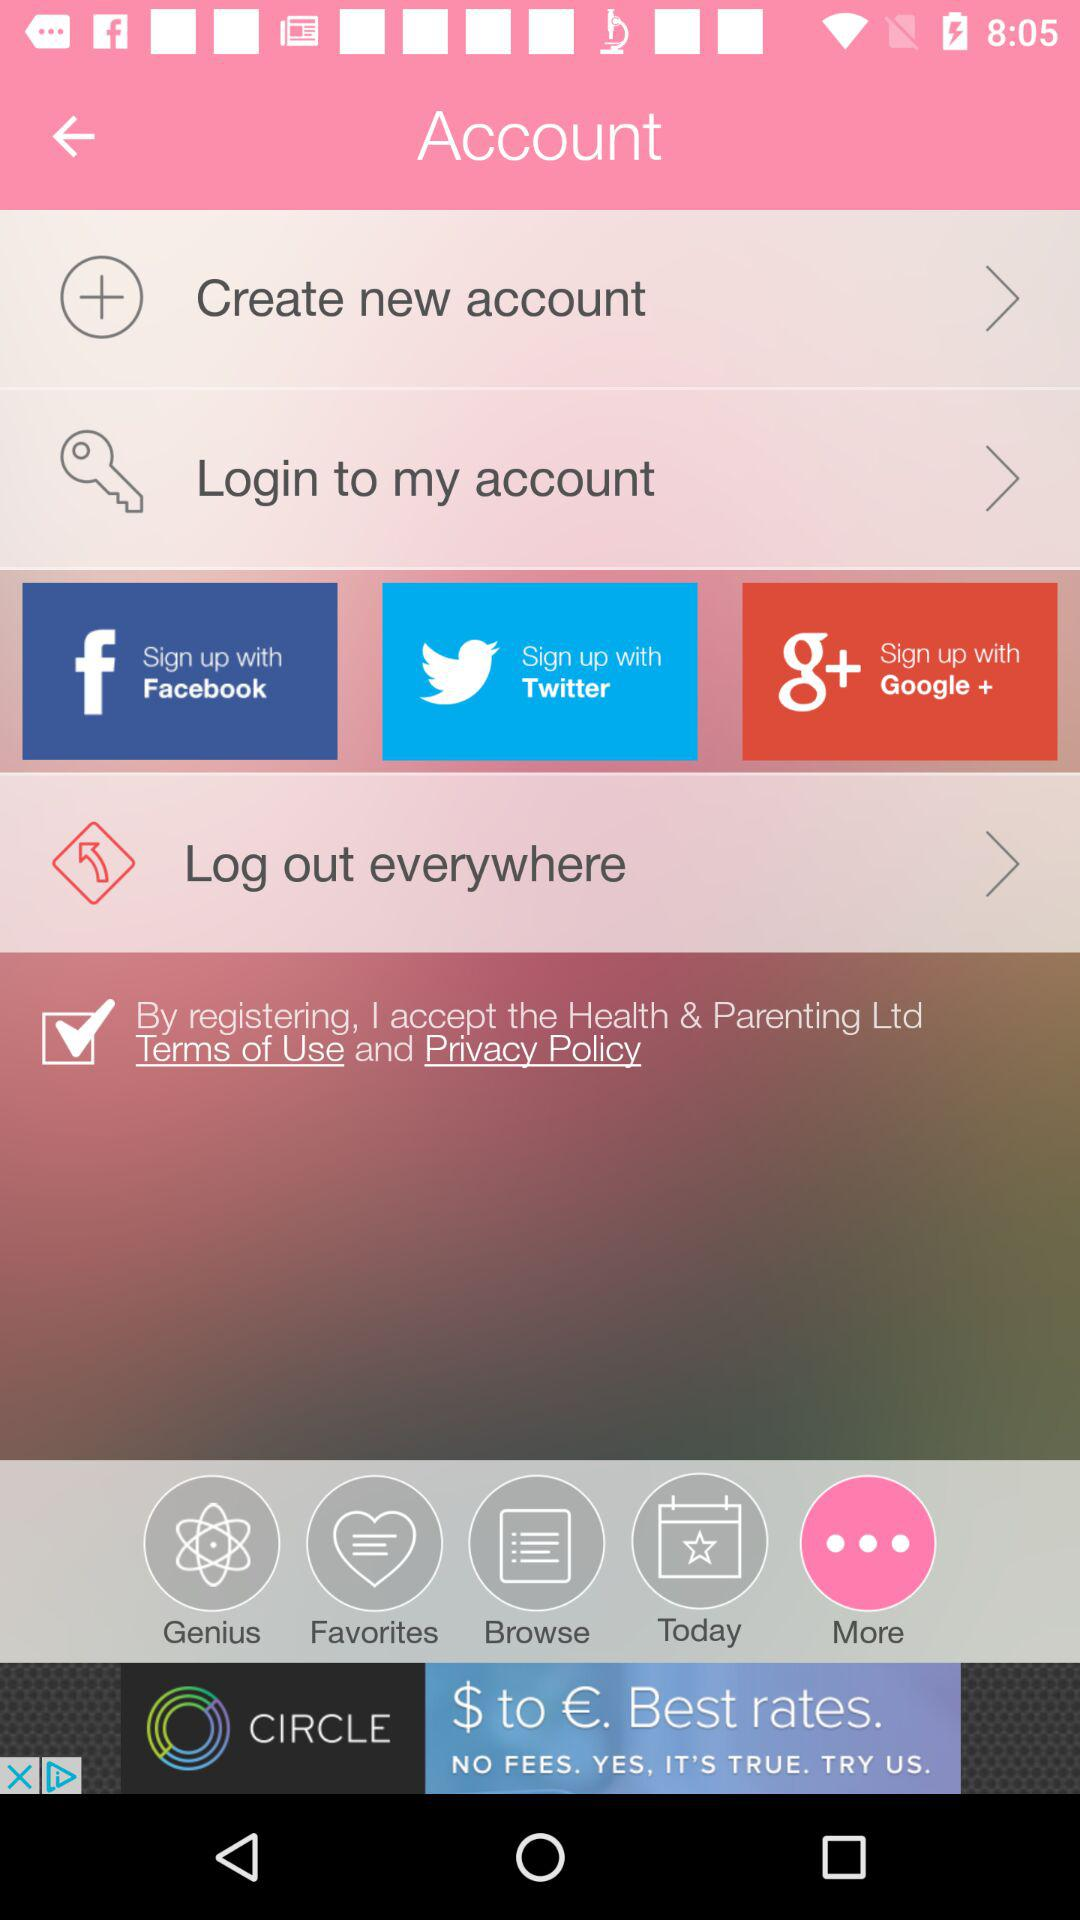Through what application we can sign up to the account? You can sign up with "Facebook", "Twitter", and "Google +". 